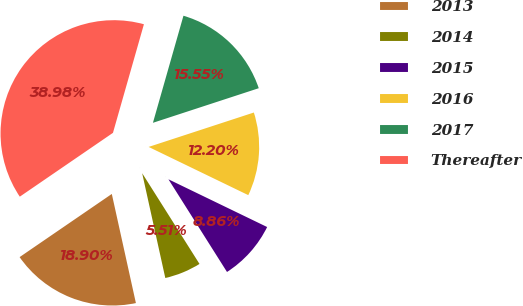<chart> <loc_0><loc_0><loc_500><loc_500><pie_chart><fcel>2013<fcel>2014<fcel>2015<fcel>2016<fcel>2017<fcel>Thereafter<nl><fcel>18.9%<fcel>5.51%<fcel>8.86%<fcel>12.2%<fcel>15.55%<fcel>38.98%<nl></chart> 